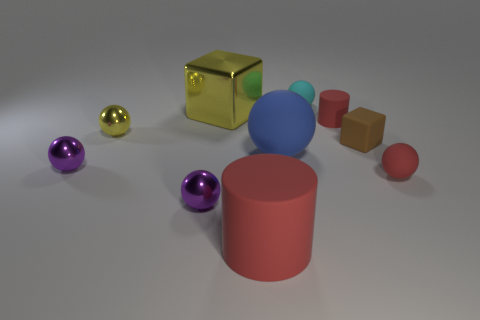Subtract all yellow cylinders. How many purple balls are left? 2 Subtract all blue balls. How many balls are left? 5 Subtract all yellow spheres. How many spheres are left? 5 Subtract 4 balls. How many balls are left? 2 Subtract all yellow spheres. Subtract all brown cubes. How many spheres are left? 5 Subtract all blocks. How many objects are left? 8 Subtract all cyan things. Subtract all cyan spheres. How many objects are left? 8 Add 3 red cylinders. How many red cylinders are left? 5 Add 9 tiny red spheres. How many tiny red spheres exist? 10 Subtract 1 cyan balls. How many objects are left? 9 